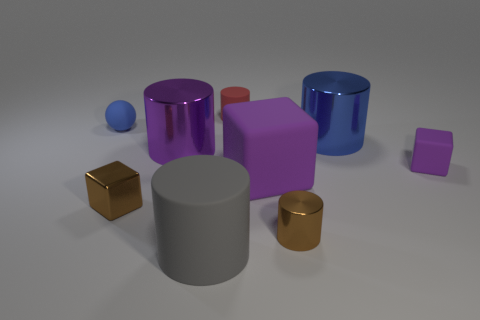Subtract all small cubes. How many cubes are left? 1 Subtract all green cylinders. How many purple cubes are left? 2 Subtract all red cylinders. How many cylinders are left? 4 Subtract all cylinders. How many objects are left? 4 Subtract 1 balls. How many balls are left? 0 Subtract all red blocks. Subtract all green cylinders. How many blocks are left? 3 Subtract all large gray matte things. Subtract all tiny blue matte things. How many objects are left? 7 Add 2 small red rubber things. How many small red rubber things are left? 3 Add 6 tiny cyan metallic balls. How many tiny cyan metallic balls exist? 6 Subtract 2 purple cubes. How many objects are left? 7 